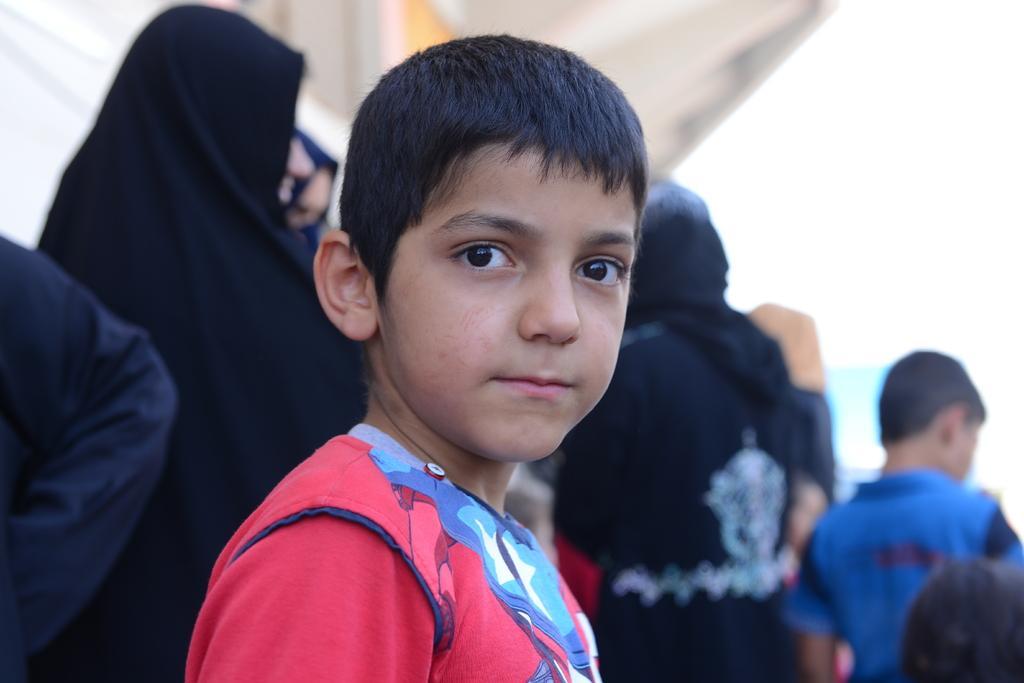Can you describe this image briefly? This is a boy standing. In the background, I can see few people standing. On the left side of the image, I can see a person´s hand. 